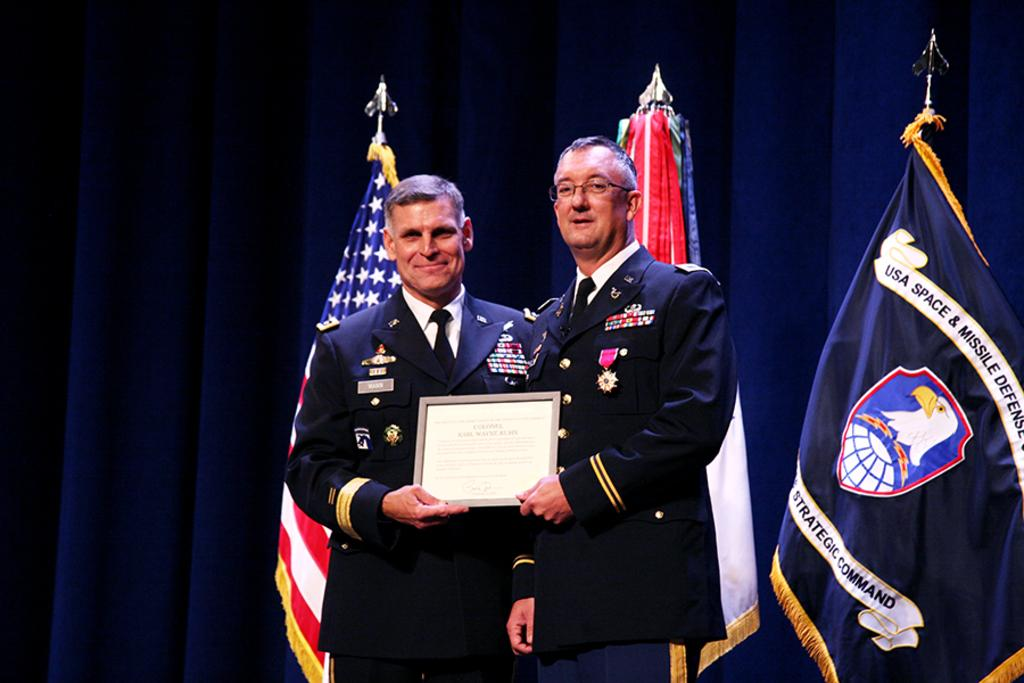<image>
Describe the image concisely. Two men stand holding a framed award in front of a flag that says "USA Space & Missile" on it. 